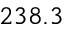<formula> <loc_0><loc_0><loc_500><loc_500>2 3 8 . 3</formula> 